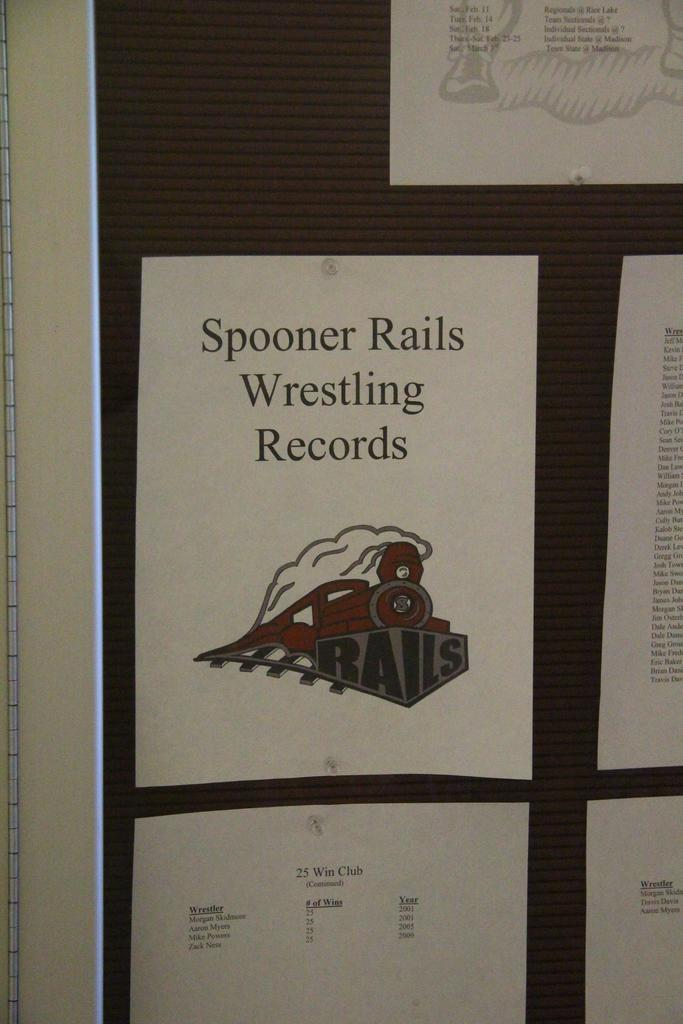Provide a one-sentence caption for the provided image. A bulletin board with the Spooner Rails Wrestling Records tacked to it. 